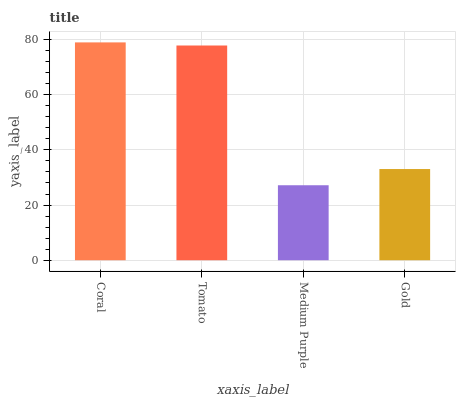Is Medium Purple the minimum?
Answer yes or no. Yes. Is Coral the maximum?
Answer yes or no. Yes. Is Tomato the minimum?
Answer yes or no. No. Is Tomato the maximum?
Answer yes or no. No. Is Coral greater than Tomato?
Answer yes or no. Yes. Is Tomato less than Coral?
Answer yes or no. Yes. Is Tomato greater than Coral?
Answer yes or no. No. Is Coral less than Tomato?
Answer yes or no. No. Is Tomato the high median?
Answer yes or no. Yes. Is Gold the low median?
Answer yes or no. Yes. Is Gold the high median?
Answer yes or no. No. Is Coral the low median?
Answer yes or no. No. 